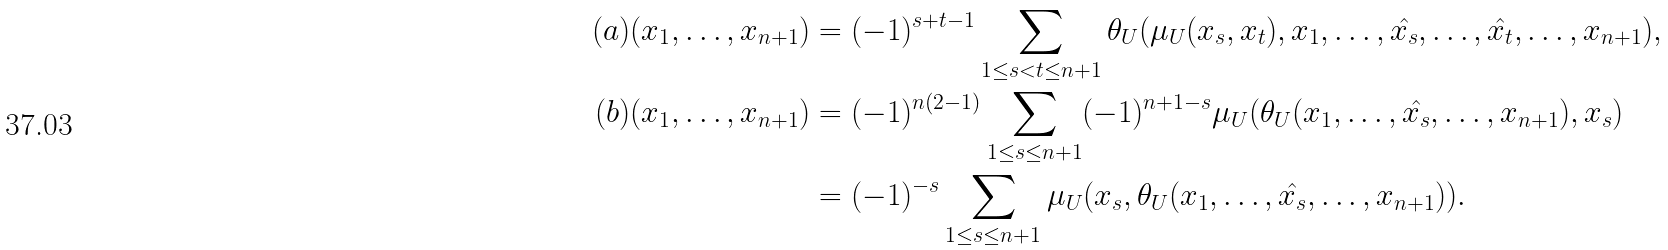<formula> <loc_0><loc_0><loc_500><loc_500>( a ) ( x _ { 1 } , \dots , x _ { n + 1 } ) & = ( - 1 ) ^ { s + t - 1 } \sum _ { 1 \leq s < t \leq n + 1 } \theta _ { U } ( \mu _ { U } ( x _ { s } , x _ { t } ) , x _ { 1 } , \dots , \hat { x _ { s } } , \dots , \hat { x _ { t } } , \dots , x _ { n + 1 } ) , \\ ( b ) ( x _ { 1 } , \dots , x _ { n + 1 } ) & = ( - 1 ) ^ { n ( 2 - 1 ) } \sum _ { 1 \leq s \leq n + 1 } ( - 1 ) ^ { n + 1 - s } \mu _ { U } ( \theta _ { U } ( x _ { 1 } , \dots , \hat { x _ { s } } , \dots , x _ { n + 1 } ) , x _ { s } ) \\ & = ( - 1 ) ^ { - s } \sum _ { 1 \leq s \leq n + 1 } \mu _ { U } ( x _ { s } , \theta _ { U } ( x _ { 1 } , \dots , \hat { x _ { s } } , \dots , x _ { n + 1 } ) ) .</formula> 